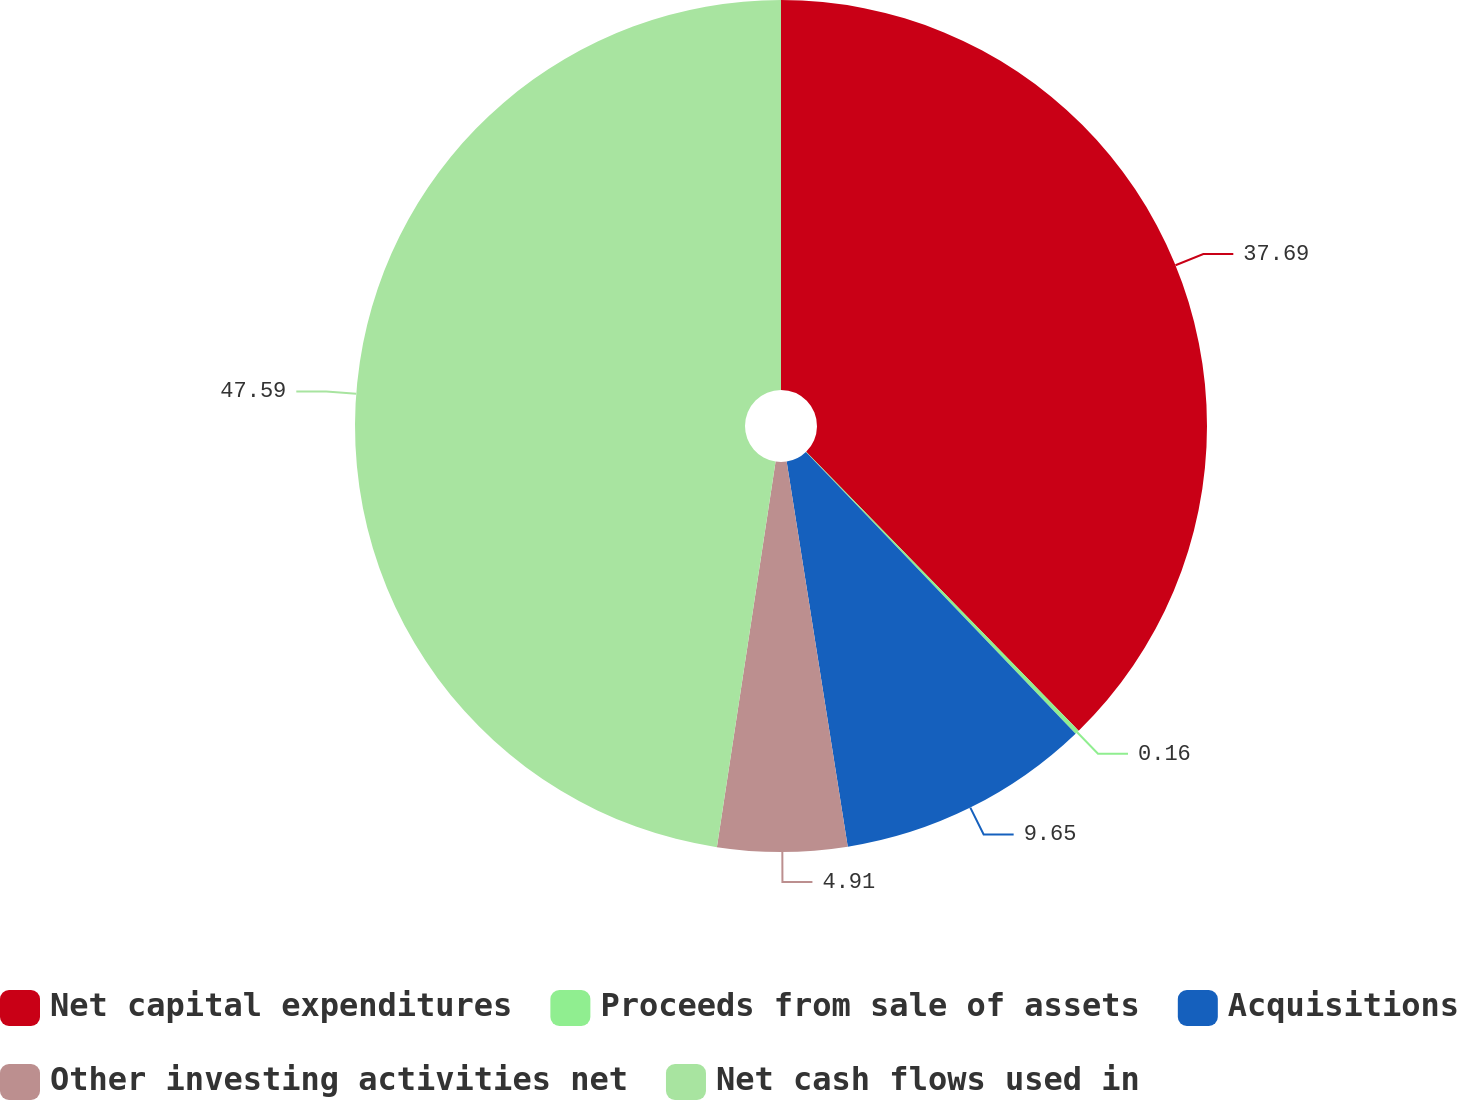Convert chart. <chart><loc_0><loc_0><loc_500><loc_500><pie_chart><fcel>Net capital expenditures<fcel>Proceeds from sale of assets<fcel>Acquisitions<fcel>Other investing activities net<fcel>Net cash flows used in<nl><fcel>37.69%<fcel>0.16%<fcel>9.65%<fcel>4.91%<fcel>47.6%<nl></chart> 